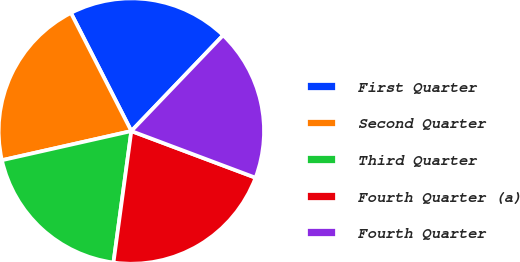<chart> <loc_0><loc_0><loc_500><loc_500><pie_chart><fcel>First Quarter<fcel>Second Quarter<fcel>Third Quarter<fcel>Fourth Quarter (a)<fcel>Fourth Quarter<nl><fcel>19.68%<fcel>21.0%<fcel>19.32%<fcel>21.43%<fcel>18.56%<nl></chart> 